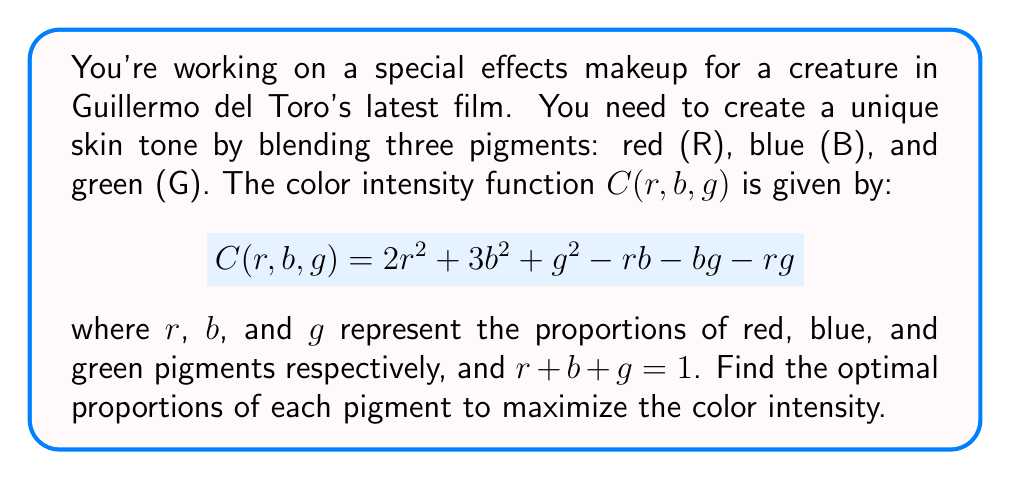Teach me how to tackle this problem. To solve this optimization problem with the constraint $r + b + g = 1$, we'll use the method of Lagrange multipliers.

Step 1: Form the Lagrangian function
$$L(r,b,g,\lambda) = C(r,b,g) - \lambda(r + b + g - 1)$$
$$L(r,b,g,\lambda) = 2r^2 + 3b^2 + g^2 - rb - bg - rg - \lambda(r + b + g - 1)$$

Step 2: Calculate partial derivatives and set them equal to zero
$$\frac{\partial L}{\partial r} = 4r - b - g - \lambda = 0$$
$$\frac{\partial L}{\partial b} = 6b - r - g - \lambda = 0$$
$$\frac{\partial L}{\partial g} = 2g - r - b - \lambda = 0$$
$$\frac{\partial L}{\partial \lambda} = r + b + g - 1 = 0$$

Step 3: Solve the system of equations
From the first three equations:
$$4r - b - g = 6b - r - g = 2g - r - b$$

Let $4r - b - g = k$. Then:
$$r = \frac{k + b + g}{4}$$
$$b = \frac{k + r + g}{6}$$
$$g = \frac{k + r + b}{2}$$

Substituting these into the constraint equation:
$$\frac{k + b + g}{4} + \frac{k + r + g}{6} + \frac{k + r + b}{2} = 1$$

Simplifying and solving for $k$:
$$k = \frac{12}{11}$$

Step 4: Calculate the proportions
$$r = \frac{12/11 + b + g}{4}$$
$$b = \frac{12/11 + r + g}{6}$$
$$g = \frac{12/11 + r + b}{2}$$

Solving this system:
$$r = \frac{4}{11}, b = \frac{3}{11}, g = \frac{4}{11}$$

Step 5: Verify the result
We can confirm that these proportions sum to 1 and satisfy the original equations.
Answer: $r = \frac{4}{11}, b = \frac{3}{11}, g = \frac{4}{11}$ 